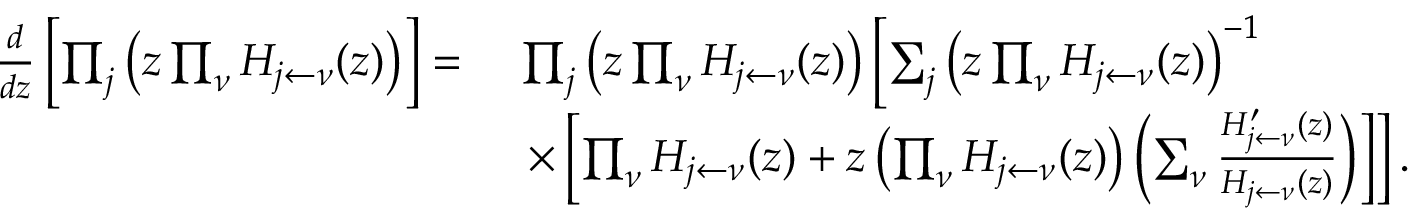Convert formula to latex. <formula><loc_0><loc_0><loc_500><loc_500>\begin{array} { r l } { \frac { d } { d z } \left [ \prod _ { j } \left ( z \prod _ { \nu } H _ { { j } \leftarrow \nu } ( z ) \right ) \right ] = } & { \ \prod _ { j } \left ( z \prod _ { \nu } H _ { { j } \leftarrow \nu } ( z ) \right ) \left [ \sum _ { j } \left ( z \prod _ { \nu } H _ { { j } \leftarrow \nu } ( z ) \right ) ^ { - 1 } } \\ & { \ \times \left [ \prod _ { \nu } H _ { { j } \leftarrow \nu } ( z ) + z \left ( \prod _ { \nu } H _ { { j } \leftarrow \nu } ( z ) \right ) \left ( \sum _ { \nu } \frac { H _ { { j } \leftarrow \nu } ^ { \prime } ( z ) } { H _ { { j } \leftarrow \nu } ( z ) } \right ) \right ] \right ] . } \end{array}</formula> 